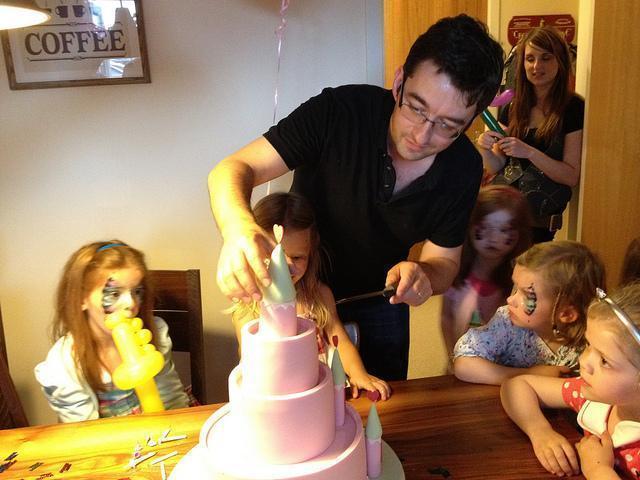Where was the castle themed birthday cake most likely created?
Make your selection and explain in format: 'Answer: answer
Rationale: rationale.'
Options: Restaurant, food bank, home kitchen, bakery. Answer: bakery.
Rationale: It looks to be professionally baked, and professional bakers typically work in a bakery. 